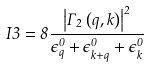Convert formula to latex. <formula><loc_0><loc_0><loc_500><loc_500>I 3 = 8 \frac { \left | \Gamma _ { 2 } \left ( q , k \right ) \right | ^ { 2 } } { \epsilon _ { q } ^ { 0 } + \epsilon _ { k + q } ^ { 0 } + \epsilon _ { k } ^ { 0 } }</formula> 